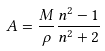Convert formula to latex. <formula><loc_0><loc_0><loc_500><loc_500>A = \frac { M } { \rho } \frac { n ^ { 2 } - 1 } { n ^ { 2 } + 2 }</formula> 